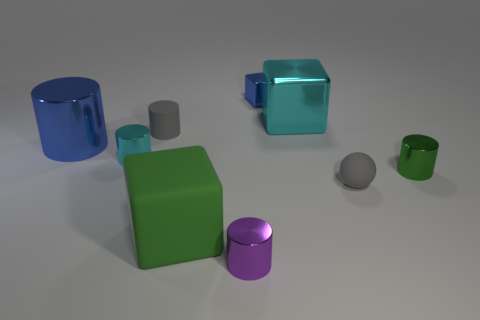Subtract 2 cylinders. How many cylinders are left? 3 Subtract all cyan cylinders. How many cylinders are left? 4 Subtract all cyan cylinders. How many cylinders are left? 4 Subtract all red cylinders. Subtract all red cubes. How many cylinders are left? 5 Add 1 cyan matte things. How many objects exist? 10 Subtract all spheres. How many objects are left? 8 Add 4 small green shiny cubes. How many small green shiny cubes exist? 4 Subtract 1 green cubes. How many objects are left? 8 Subtract all tiny green metal cylinders. Subtract all green metal cylinders. How many objects are left? 7 Add 4 gray rubber cylinders. How many gray rubber cylinders are left? 5 